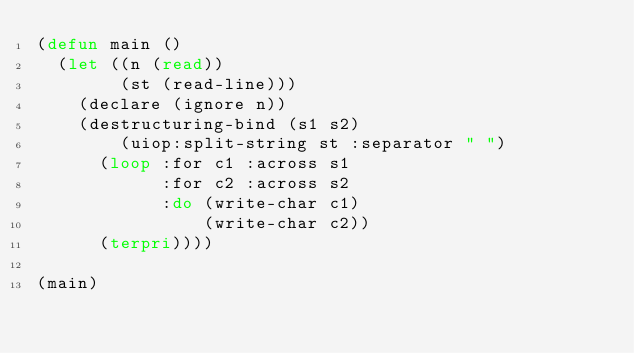<code> <loc_0><loc_0><loc_500><loc_500><_Lisp_>(defun main ()
  (let ((n (read))
        (st (read-line)))
    (declare (ignore n))
    (destructuring-bind (s1 s2)
        (uiop:split-string st :separator " ")
      (loop :for c1 :across s1
            :for c2 :across s2
            :do (write-char c1)
                (write-char c2))
      (terpri))))

(main)

</code> 